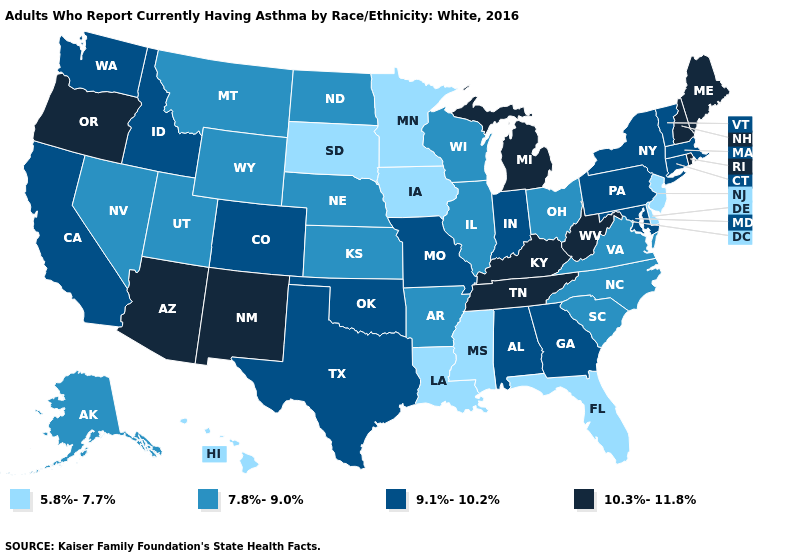What is the value of North Carolina?
Keep it brief. 7.8%-9.0%. Among the states that border New Jersey , does Pennsylvania have the lowest value?
Short answer required. No. How many symbols are there in the legend?
Short answer required. 4. Does Colorado have a lower value than Montana?
Write a very short answer. No. What is the value of Arizona?
Be succinct. 10.3%-11.8%. Among the states that border Maine , which have the lowest value?
Keep it brief. New Hampshire. What is the value of South Dakota?
Concise answer only. 5.8%-7.7%. Is the legend a continuous bar?
Short answer required. No. What is the value of Maine?
Write a very short answer. 10.3%-11.8%. Does Delaware have the highest value in the South?
Answer briefly. No. Is the legend a continuous bar?
Concise answer only. No. Name the states that have a value in the range 10.3%-11.8%?
Answer briefly. Arizona, Kentucky, Maine, Michigan, New Hampshire, New Mexico, Oregon, Rhode Island, Tennessee, West Virginia. What is the highest value in the South ?
Be succinct. 10.3%-11.8%. Name the states that have a value in the range 7.8%-9.0%?
Give a very brief answer. Alaska, Arkansas, Illinois, Kansas, Montana, Nebraska, Nevada, North Carolina, North Dakota, Ohio, South Carolina, Utah, Virginia, Wisconsin, Wyoming. Name the states that have a value in the range 10.3%-11.8%?
Quick response, please. Arizona, Kentucky, Maine, Michigan, New Hampshire, New Mexico, Oregon, Rhode Island, Tennessee, West Virginia. 